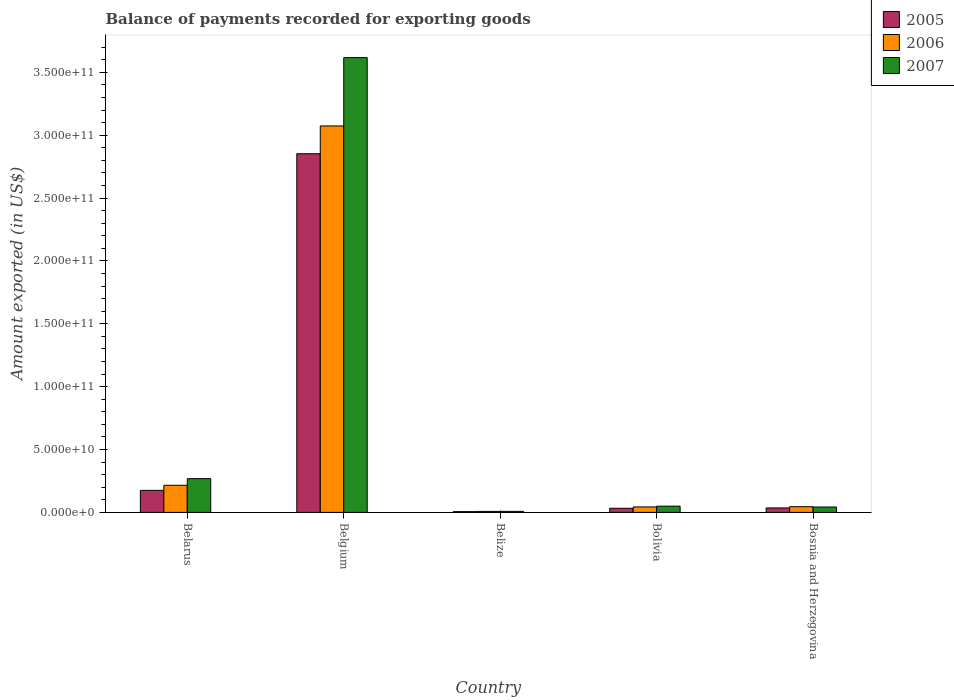Are the number of bars per tick equal to the number of legend labels?
Your response must be concise. Yes. What is the label of the 3rd group of bars from the left?
Offer a very short reply. Belize. In how many cases, is the number of bars for a given country not equal to the number of legend labels?
Give a very brief answer. 0. What is the amount exported in 2007 in Bolivia?
Offer a terse response. 4.95e+09. Across all countries, what is the maximum amount exported in 2005?
Ensure brevity in your answer.  2.85e+11. Across all countries, what is the minimum amount exported in 2007?
Ensure brevity in your answer.  8.16e+08. In which country was the amount exported in 2005 minimum?
Make the answer very short. Belize. What is the total amount exported in 2005 in the graph?
Your answer should be very brief. 3.10e+11. What is the difference between the amount exported in 2005 in Belgium and that in Belize?
Your response must be concise. 2.85e+11. What is the difference between the amount exported in 2007 in Bolivia and the amount exported in 2006 in Belize?
Offer a very short reply. 4.18e+09. What is the average amount exported in 2007 per country?
Your answer should be very brief. 7.97e+1. What is the difference between the amount exported of/in 2007 and amount exported of/in 2006 in Belarus?
Provide a succinct answer. 5.28e+09. In how many countries, is the amount exported in 2006 greater than 50000000000 US$?
Offer a very short reply. 1. What is the ratio of the amount exported in 2005 in Belize to that in Bosnia and Herzegovina?
Give a very brief answer. 0.17. Is the amount exported in 2005 in Belize less than that in Bolivia?
Keep it short and to the point. Yes. What is the difference between the highest and the second highest amount exported in 2007?
Your answer should be compact. 3.35e+11. What is the difference between the highest and the lowest amount exported in 2006?
Your answer should be very brief. 3.07e+11. What does the 3rd bar from the left in Bosnia and Herzegovina represents?
Your answer should be very brief. 2007. Is it the case that in every country, the sum of the amount exported in 2006 and amount exported in 2005 is greater than the amount exported in 2007?
Your response must be concise. Yes. How many countries are there in the graph?
Your answer should be compact. 5. What is the difference between two consecutive major ticks on the Y-axis?
Your response must be concise. 5.00e+1. Does the graph contain any zero values?
Ensure brevity in your answer.  No. Where does the legend appear in the graph?
Ensure brevity in your answer.  Top right. How are the legend labels stacked?
Your answer should be very brief. Vertical. What is the title of the graph?
Your answer should be compact. Balance of payments recorded for exporting goods. What is the label or title of the Y-axis?
Provide a short and direct response. Amount exported (in US$). What is the Amount exported (in US$) in 2005 in Belarus?
Make the answer very short. 1.75e+1. What is the Amount exported (in US$) in 2006 in Belarus?
Provide a succinct answer. 2.16e+1. What is the Amount exported (in US$) of 2007 in Belarus?
Keep it short and to the point. 2.69e+1. What is the Amount exported (in US$) in 2005 in Belgium?
Ensure brevity in your answer.  2.85e+11. What is the Amount exported (in US$) in 2006 in Belgium?
Your answer should be very brief. 3.07e+11. What is the Amount exported (in US$) of 2007 in Belgium?
Make the answer very short. 3.62e+11. What is the Amount exported (in US$) of 2005 in Belize?
Your answer should be very brief. 6.15e+08. What is the Amount exported (in US$) of 2006 in Belize?
Ensure brevity in your answer.  7.76e+08. What is the Amount exported (in US$) of 2007 in Belize?
Make the answer very short. 8.16e+08. What is the Amount exported (in US$) of 2005 in Bolivia?
Provide a short and direct response. 3.28e+09. What is the Amount exported (in US$) of 2006 in Bolivia?
Keep it short and to the point. 4.35e+09. What is the Amount exported (in US$) in 2007 in Bolivia?
Provide a succinct answer. 4.95e+09. What is the Amount exported (in US$) of 2005 in Bosnia and Herzegovina?
Ensure brevity in your answer.  3.54e+09. What is the Amount exported (in US$) in 2006 in Bosnia and Herzegovina?
Give a very brief answer. 4.52e+09. What is the Amount exported (in US$) of 2007 in Bosnia and Herzegovina?
Make the answer very short. 4.29e+09. Across all countries, what is the maximum Amount exported (in US$) of 2005?
Give a very brief answer. 2.85e+11. Across all countries, what is the maximum Amount exported (in US$) in 2006?
Offer a terse response. 3.07e+11. Across all countries, what is the maximum Amount exported (in US$) in 2007?
Your answer should be very brief. 3.62e+11. Across all countries, what is the minimum Amount exported (in US$) in 2005?
Offer a terse response. 6.15e+08. Across all countries, what is the minimum Amount exported (in US$) of 2006?
Provide a short and direct response. 7.76e+08. Across all countries, what is the minimum Amount exported (in US$) of 2007?
Make the answer very short. 8.16e+08. What is the total Amount exported (in US$) of 2005 in the graph?
Your answer should be compact. 3.10e+11. What is the total Amount exported (in US$) in 2006 in the graph?
Provide a succinct answer. 3.39e+11. What is the total Amount exported (in US$) of 2007 in the graph?
Offer a terse response. 3.99e+11. What is the difference between the Amount exported (in US$) in 2005 in Belarus and that in Belgium?
Offer a terse response. -2.68e+11. What is the difference between the Amount exported (in US$) in 2006 in Belarus and that in Belgium?
Offer a terse response. -2.86e+11. What is the difference between the Amount exported (in US$) in 2007 in Belarus and that in Belgium?
Your answer should be compact. -3.35e+11. What is the difference between the Amount exported (in US$) in 2005 in Belarus and that in Belize?
Provide a succinct answer. 1.69e+1. What is the difference between the Amount exported (in US$) of 2006 in Belarus and that in Belize?
Offer a very short reply. 2.08e+1. What is the difference between the Amount exported (in US$) in 2007 in Belarus and that in Belize?
Your answer should be very brief. 2.60e+1. What is the difference between the Amount exported (in US$) of 2005 in Belarus and that in Bolivia?
Provide a short and direct response. 1.43e+1. What is the difference between the Amount exported (in US$) of 2006 in Belarus and that in Bolivia?
Your response must be concise. 1.72e+1. What is the difference between the Amount exported (in US$) in 2007 in Belarus and that in Bolivia?
Offer a very short reply. 2.19e+1. What is the difference between the Amount exported (in US$) of 2005 in Belarus and that in Bosnia and Herzegovina?
Your response must be concise. 1.40e+1. What is the difference between the Amount exported (in US$) in 2006 in Belarus and that in Bosnia and Herzegovina?
Offer a very short reply. 1.70e+1. What is the difference between the Amount exported (in US$) in 2007 in Belarus and that in Bosnia and Herzegovina?
Your answer should be very brief. 2.26e+1. What is the difference between the Amount exported (in US$) in 2005 in Belgium and that in Belize?
Offer a terse response. 2.85e+11. What is the difference between the Amount exported (in US$) in 2006 in Belgium and that in Belize?
Provide a succinct answer. 3.07e+11. What is the difference between the Amount exported (in US$) in 2007 in Belgium and that in Belize?
Your answer should be compact. 3.61e+11. What is the difference between the Amount exported (in US$) in 2005 in Belgium and that in Bolivia?
Offer a terse response. 2.82e+11. What is the difference between the Amount exported (in US$) in 2006 in Belgium and that in Bolivia?
Your answer should be very brief. 3.03e+11. What is the difference between the Amount exported (in US$) in 2007 in Belgium and that in Bolivia?
Offer a terse response. 3.57e+11. What is the difference between the Amount exported (in US$) in 2005 in Belgium and that in Bosnia and Herzegovina?
Ensure brevity in your answer.  2.82e+11. What is the difference between the Amount exported (in US$) in 2006 in Belgium and that in Bosnia and Herzegovina?
Ensure brevity in your answer.  3.03e+11. What is the difference between the Amount exported (in US$) in 2007 in Belgium and that in Bosnia and Herzegovina?
Ensure brevity in your answer.  3.57e+11. What is the difference between the Amount exported (in US$) of 2005 in Belize and that in Bolivia?
Provide a short and direct response. -2.66e+09. What is the difference between the Amount exported (in US$) of 2006 in Belize and that in Bolivia?
Offer a very short reply. -3.57e+09. What is the difference between the Amount exported (in US$) of 2007 in Belize and that in Bolivia?
Offer a terse response. -4.14e+09. What is the difference between the Amount exported (in US$) of 2005 in Belize and that in Bosnia and Herzegovina?
Provide a succinct answer. -2.93e+09. What is the difference between the Amount exported (in US$) in 2006 in Belize and that in Bosnia and Herzegovina?
Your response must be concise. -3.75e+09. What is the difference between the Amount exported (in US$) in 2007 in Belize and that in Bosnia and Herzegovina?
Provide a short and direct response. -3.47e+09. What is the difference between the Amount exported (in US$) in 2005 in Bolivia and that in Bosnia and Herzegovina?
Keep it short and to the point. -2.65e+08. What is the difference between the Amount exported (in US$) of 2006 in Bolivia and that in Bosnia and Herzegovina?
Keep it short and to the point. -1.72e+08. What is the difference between the Amount exported (in US$) in 2007 in Bolivia and that in Bosnia and Herzegovina?
Give a very brief answer. 6.67e+08. What is the difference between the Amount exported (in US$) in 2005 in Belarus and the Amount exported (in US$) in 2006 in Belgium?
Provide a short and direct response. -2.90e+11. What is the difference between the Amount exported (in US$) in 2005 in Belarus and the Amount exported (in US$) in 2007 in Belgium?
Provide a short and direct response. -3.44e+11. What is the difference between the Amount exported (in US$) in 2006 in Belarus and the Amount exported (in US$) in 2007 in Belgium?
Your answer should be compact. -3.40e+11. What is the difference between the Amount exported (in US$) in 2005 in Belarus and the Amount exported (in US$) in 2006 in Belize?
Your response must be concise. 1.68e+1. What is the difference between the Amount exported (in US$) in 2005 in Belarus and the Amount exported (in US$) in 2007 in Belize?
Offer a terse response. 1.67e+1. What is the difference between the Amount exported (in US$) of 2006 in Belarus and the Amount exported (in US$) of 2007 in Belize?
Offer a terse response. 2.08e+1. What is the difference between the Amount exported (in US$) in 2005 in Belarus and the Amount exported (in US$) in 2006 in Bolivia?
Provide a succinct answer. 1.32e+1. What is the difference between the Amount exported (in US$) of 2005 in Belarus and the Amount exported (in US$) of 2007 in Bolivia?
Give a very brief answer. 1.26e+1. What is the difference between the Amount exported (in US$) in 2006 in Belarus and the Amount exported (in US$) in 2007 in Bolivia?
Provide a short and direct response. 1.66e+1. What is the difference between the Amount exported (in US$) in 2005 in Belarus and the Amount exported (in US$) in 2006 in Bosnia and Herzegovina?
Give a very brief answer. 1.30e+1. What is the difference between the Amount exported (in US$) in 2005 in Belarus and the Amount exported (in US$) in 2007 in Bosnia and Herzegovina?
Your answer should be compact. 1.32e+1. What is the difference between the Amount exported (in US$) of 2006 in Belarus and the Amount exported (in US$) of 2007 in Bosnia and Herzegovina?
Ensure brevity in your answer.  1.73e+1. What is the difference between the Amount exported (in US$) of 2005 in Belgium and the Amount exported (in US$) of 2006 in Belize?
Your answer should be very brief. 2.85e+11. What is the difference between the Amount exported (in US$) in 2005 in Belgium and the Amount exported (in US$) in 2007 in Belize?
Make the answer very short. 2.85e+11. What is the difference between the Amount exported (in US$) in 2006 in Belgium and the Amount exported (in US$) in 2007 in Belize?
Provide a succinct answer. 3.07e+11. What is the difference between the Amount exported (in US$) in 2005 in Belgium and the Amount exported (in US$) in 2006 in Bolivia?
Give a very brief answer. 2.81e+11. What is the difference between the Amount exported (in US$) of 2005 in Belgium and the Amount exported (in US$) of 2007 in Bolivia?
Ensure brevity in your answer.  2.80e+11. What is the difference between the Amount exported (in US$) of 2006 in Belgium and the Amount exported (in US$) of 2007 in Bolivia?
Ensure brevity in your answer.  3.02e+11. What is the difference between the Amount exported (in US$) in 2005 in Belgium and the Amount exported (in US$) in 2006 in Bosnia and Herzegovina?
Provide a succinct answer. 2.81e+11. What is the difference between the Amount exported (in US$) in 2005 in Belgium and the Amount exported (in US$) in 2007 in Bosnia and Herzegovina?
Provide a short and direct response. 2.81e+11. What is the difference between the Amount exported (in US$) in 2006 in Belgium and the Amount exported (in US$) in 2007 in Bosnia and Herzegovina?
Your response must be concise. 3.03e+11. What is the difference between the Amount exported (in US$) of 2005 in Belize and the Amount exported (in US$) of 2006 in Bolivia?
Make the answer very short. -3.73e+09. What is the difference between the Amount exported (in US$) in 2005 in Belize and the Amount exported (in US$) in 2007 in Bolivia?
Provide a succinct answer. -4.34e+09. What is the difference between the Amount exported (in US$) of 2006 in Belize and the Amount exported (in US$) of 2007 in Bolivia?
Make the answer very short. -4.18e+09. What is the difference between the Amount exported (in US$) of 2005 in Belize and the Amount exported (in US$) of 2006 in Bosnia and Herzegovina?
Keep it short and to the point. -3.91e+09. What is the difference between the Amount exported (in US$) of 2005 in Belize and the Amount exported (in US$) of 2007 in Bosnia and Herzegovina?
Your answer should be compact. -3.67e+09. What is the difference between the Amount exported (in US$) in 2006 in Belize and the Amount exported (in US$) in 2007 in Bosnia and Herzegovina?
Your answer should be very brief. -3.51e+09. What is the difference between the Amount exported (in US$) in 2005 in Bolivia and the Amount exported (in US$) in 2006 in Bosnia and Herzegovina?
Your response must be concise. -1.24e+09. What is the difference between the Amount exported (in US$) in 2005 in Bolivia and the Amount exported (in US$) in 2007 in Bosnia and Herzegovina?
Give a very brief answer. -1.01e+09. What is the difference between the Amount exported (in US$) in 2006 in Bolivia and the Amount exported (in US$) in 2007 in Bosnia and Herzegovina?
Your response must be concise. 6.18e+07. What is the average Amount exported (in US$) in 2005 per country?
Your response must be concise. 6.21e+1. What is the average Amount exported (in US$) in 2006 per country?
Give a very brief answer. 6.77e+1. What is the average Amount exported (in US$) of 2007 per country?
Ensure brevity in your answer.  7.97e+1. What is the difference between the Amount exported (in US$) of 2005 and Amount exported (in US$) of 2006 in Belarus?
Offer a very short reply. -4.03e+09. What is the difference between the Amount exported (in US$) of 2005 and Amount exported (in US$) of 2007 in Belarus?
Provide a short and direct response. -9.32e+09. What is the difference between the Amount exported (in US$) in 2006 and Amount exported (in US$) in 2007 in Belarus?
Keep it short and to the point. -5.28e+09. What is the difference between the Amount exported (in US$) of 2005 and Amount exported (in US$) of 2006 in Belgium?
Provide a succinct answer. -2.21e+1. What is the difference between the Amount exported (in US$) in 2005 and Amount exported (in US$) in 2007 in Belgium?
Your response must be concise. -7.65e+1. What is the difference between the Amount exported (in US$) in 2006 and Amount exported (in US$) in 2007 in Belgium?
Your response must be concise. -5.44e+1. What is the difference between the Amount exported (in US$) in 2005 and Amount exported (in US$) in 2006 in Belize?
Give a very brief answer. -1.61e+08. What is the difference between the Amount exported (in US$) in 2005 and Amount exported (in US$) in 2007 in Belize?
Offer a terse response. -2.01e+08. What is the difference between the Amount exported (in US$) in 2006 and Amount exported (in US$) in 2007 in Belize?
Make the answer very short. -4.04e+07. What is the difference between the Amount exported (in US$) in 2005 and Amount exported (in US$) in 2006 in Bolivia?
Your response must be concise. -1.07e+09. What is the difference between the Amount exported (in US$) of 2005 and Amount exported (in US$) of 2007 in Bolivia?
Provide a short and direct response. -1.68e+09. What is the difference between the Amount exported (in US$) in 2006 and Amount exported (in US$) in 2007 in Bolivia?
Offer a terse response. -6.05e+08. What is the difference between the Amount exported (in US$) in 2005 and Amount exported (in US$) in 2006 in Bosnia and Herzegovina?
Ensure brevity in your answer.  -9.77e+08. What is the difference between the Amount exported (in US$) of 2005 and Amount exported (in US$) of 2007 in Bosnia and Herzegovina?
Your answer should be compact. -7.43e+08. What is the difference between the Amount exported (in US$) of 2006 and Amount exported (in US$) of 2007 in Bosnia and Herzegovina?
Your response must be concise. 2.34e+08. What is the ratio of the Amount exported (in US$) of 2005 in Belarus to that in Belgium?
Give a very brief answer. 0.06. What is the ratio of the Amount exported (in US$) in 2006 in Belarus to that in Belgium?
Keep it short and to the point. 0.07. What is the ratio of the Amount exported (in US$) in 2007 in Belarus to that in Belgium?
Offer a terse response. 0.07. What is the ratio of the Amount exported (in US$) in 2005 in Belarus to that in Belize?
Provide a succinct answer. 28.51. What is the ratio of the Amount exported (in US$) in 2006 in Belarus to that in Belize?
Provide a short and direct response. 27.8. What is the ratio of the Amount exported (in US$) of 2007 in Belarus to that in Belize?
Keep it short and to the point. 32.89. What is the ratio of the Amount exported (in US$) of 2005 in Belarus to that in Bolivia?
Make the answer very short. 5.35. What is the ratio of the Amount exported (in US$) of 2006 in Belarus to that in Bolivia?
Your answer should be compact. 4.96. What is the ratio of the Amount exported (in US$) of 2007 in Belarus to that in Bolivia?
Offer a terse response. 5.42. What is the ratio of the Amount exported (in US$) in 2005 in Belarus to that in Bosnia and Herzegovina?
Give a very brief answer. 4.95. What is the ratio of the Amount exported (in US$) in 2006 in Belarus to that in Bosnia and Herzegovina?
Your response must be concise. 4.77. What is the ratio of the Amount exported (in US$) of 2007 in Belarus to that in Bosnia and Herzegovina?
Provide a short and direct response. 6.26. What is the ratio of the Amount exported (in US$) of 2005 in Belgium to that in Belize?
Keep it short and to the point. 463.93. What is the ratio of the Amount exported (in US$) of 2006 in Belgium to that in Belize?
Make the answer very short. 396.18. What is the ratio of the Amount exported (in US$) in 2007 in Belgium to that in Belize?
Provide a short and direct response. 443.16. What is the ratio of the Amount exported (in US$) of 2005 in Belgium to that in Bolivia?
Offer a very short reply. 87. What is the ratio of the Amount exported (in US$) of 2006 in Belgium to that in Bolivia?
Make the answer very short. 70.68. What is the ratio of the Amount exported (in US$) of 2007 in Belgium to that in Bolivia?
Offer a terse response. 73.02. What is the ratio of the Amount exported (in US$) in 2005 in Belgium to that in Bosnia and Herzegovina?
Give a very brief answer. 80.5. What is the ratio of the Amount exported (in US$) of 2006 in Belgium to that in Bosnia and Herzegovina?
Make the answer very short. 68. What is the ratio of the Amount exported (in US$) of 2007 in Belgium to that in Bosnia and Herzegovina?
Keep it short and to the point. 84.38. What is the ratio of the Amount exported (in US$) in 2005 in Belize to that in Bolivia?
Give a very brief answer. 0.19. What is the ratio of the Amount exported (in US$) of 2006 in Belize to that in Bolivia?
Your response must be concise. 0.18. What is the ratio of the Amount exported (in US$) of 2007 in Belize to that in Bolivia?
Give a very brief answer. 0.16. What is the ratio of the Amount exported (in US$) in 2005 in Belize to that in Bosnia and Herzegovina?
Keep it short and to the point. 0.17. What is the ratio of the Amount exported (in US$) in 2006 in Belize to that in Bosnia and Herzegovina?
Keep it short and to the point. 0.17. What is the ratio of the Amount exported (in US$) of 2007 in Belize to that in Bosnia and Herzegovina?
Offer a very short reply. 0.19. What is the ratio of the Amount exported (in US$) of 2005 in Bolivia to that in Bosnia and Herzegovina?
Your answer should be very brief. 0.93. What is the ratio of the Amount exported (in US$) in 2006 in Bolivia to that in Bosnia and Herzegovina?
Make the answer very short. 0.96. What is the ratio of the Amount exported (in US$) of 2007 in Bolivia to that in Bosnia and Herzegovina?
Offer a terse response. 1.16. What is the difference between the highest and the second highest Amount exported (in US$) of 2005?
Your response must be concise. 2.68e+11. What is the difference between the highest and the second highest Amount exported (in US$) of 2006?
Provide a short and direct response. 2.86e+11. What is the difference between the highest and the second highest Amount exported (in US$) of 2007?
Your answer should be very brief. 3.35e+11. What is the difference between the highest and the lowest Amount exported (in US$) of 2005?
Keep it short and to the point. 2.85e+11. What is the difference between the highest and the lowest Amount exported (in US$) of 2006?
Provide a succinct answer. 3.07e+11. What is the difference between the highest and the lowest Amount exported (in US$) in 2007?
Offer a very short reply. 3.61e+11. 